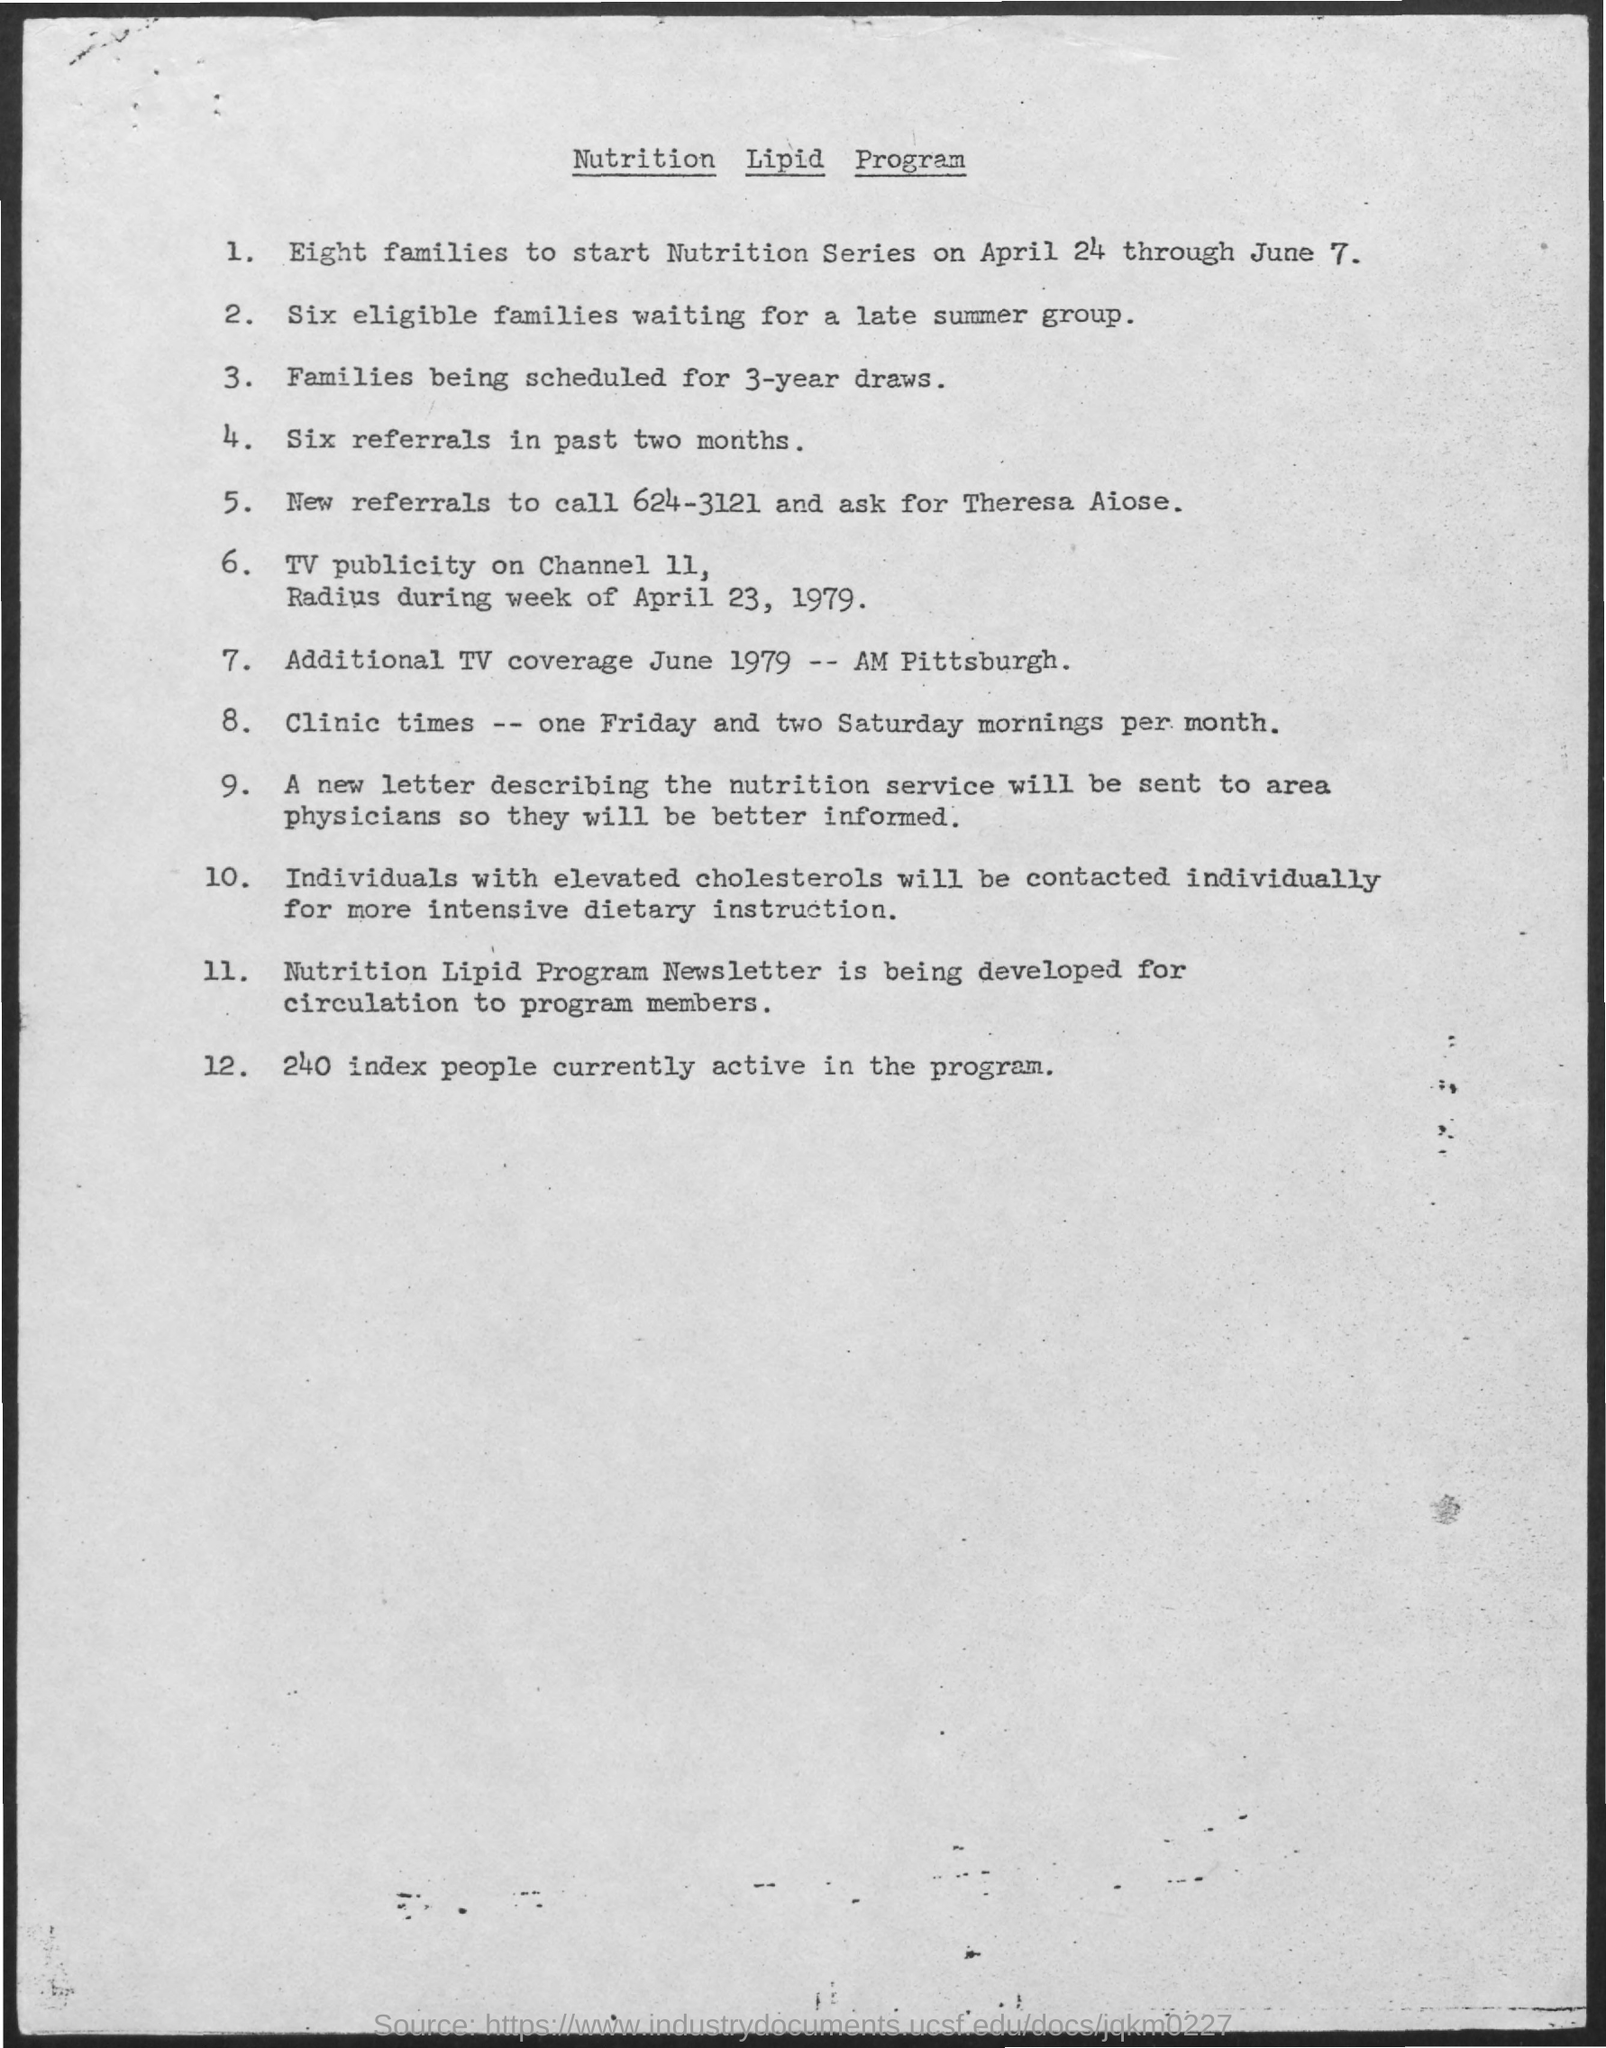What is the name of the program ?
Provide a short and direct response. Nutrition lipid program. How many index people are currently active in the program ?
Ensure brevity in your answer.  240. What is the number given for new referrals to call ?
Keep it short and to the point. 624-3121. On which channel the tv publicity will come ?
Your answer should be very brief. CHANNEL 11. 